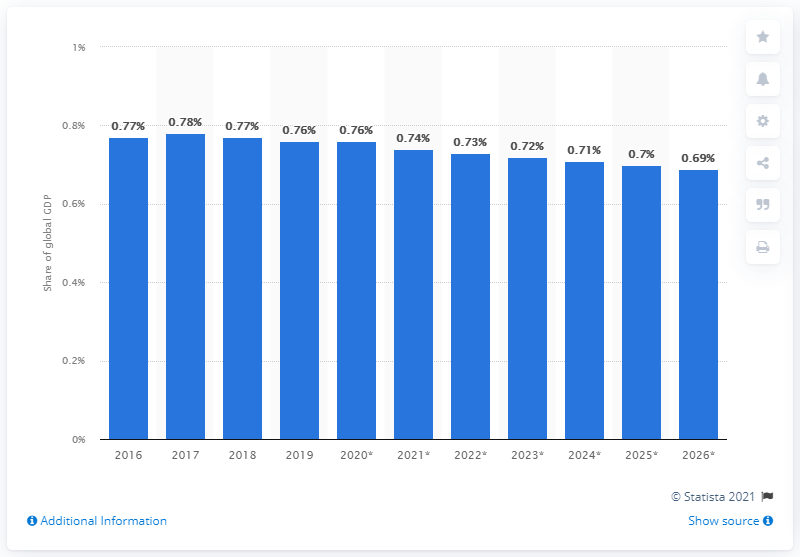Specify some key components in this picture. In 2019, the Netherlands' share of global GDP was 0.76. 